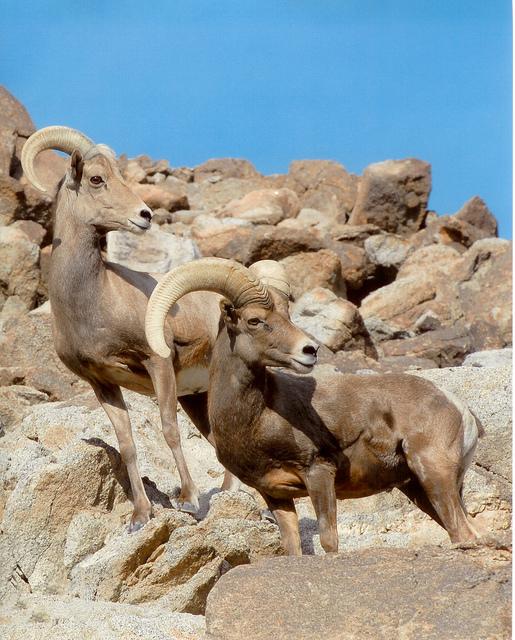How many horns?
Be succinct. 4. Where was the picture taken of the goats?
Give a very brief answer. Mountains. What way are they looking?
Keep it brief. Right. Are both Rams male?
Answer briefly. Yes. Do these animals have a familiar name?
Keep it brief. Yes. What animal is in the photo?
Concise answer only. Ram. 